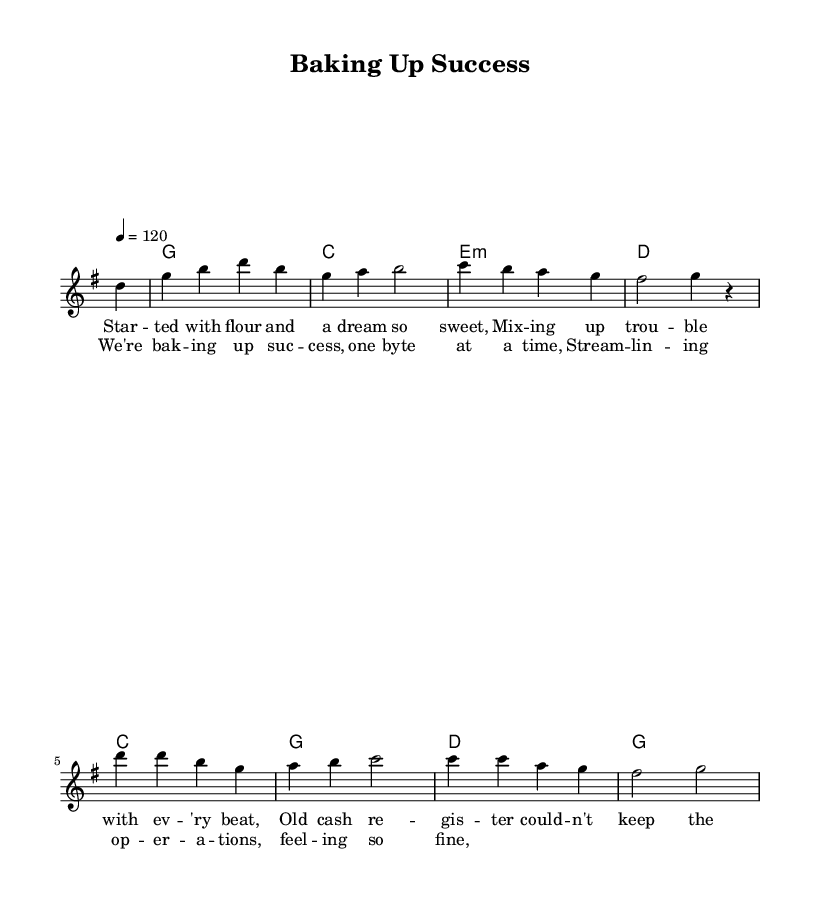What is the key signature of this music? The key signature is G major, indicated by one sharp (F#) at the beginning of the staff.
Answer: G major What is the time signature of this music? The time signature is 4/4, as denoted at the beginning of the piece, which means there are four beats in each measure.
Answer: 4/4 What is the tempo marking of this piece? The tempo marking is 120 beats per minute, shown at the beginning with the instruction "4 = 120."
Answer: 120 How many measures are in the melody? There are eight measures in the melody, as counted from the beginning of the piece to the end of the provided melody line.
Answer: Eight What type of system is identified in the lyrics? The lyrics describe a system to streamline operations in a bakery setting, specifically mentioning a cash register and a new system to increase efficiency.
Answer: System What is the overall theme of the lyrics? The overall theme of the lyrics centers around achieving success through innovation and technology in bakery operations, illustrating challenges and triumphs.
Answer: Overcoming challenges What is the main subject of the chorus? The main subject of the chorus is baking success and improving operations with technology, encapsulating the essence of the song's message about efficiency in baking.
Answer: Baking success 